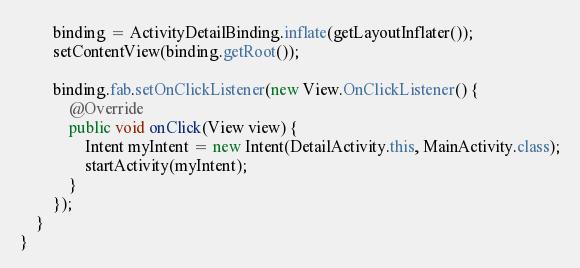Convert code to text. <code><loc_0><loc_0><loc_500><loc_500><_Java_>        binding = ActivityDetailBinding.inflate(getLayoutInflater());
        setContentView(binding.getRoot());

        binding.fab.setOnClickListener(new View.OnClickListener() {
            @Override
            public void onClick(View view) {
                Intent myIntent = new Intent(DetailActivity.this, MainActivity.class);
                startActivity(myIntent);
            }
        });
    }
}
</code> 